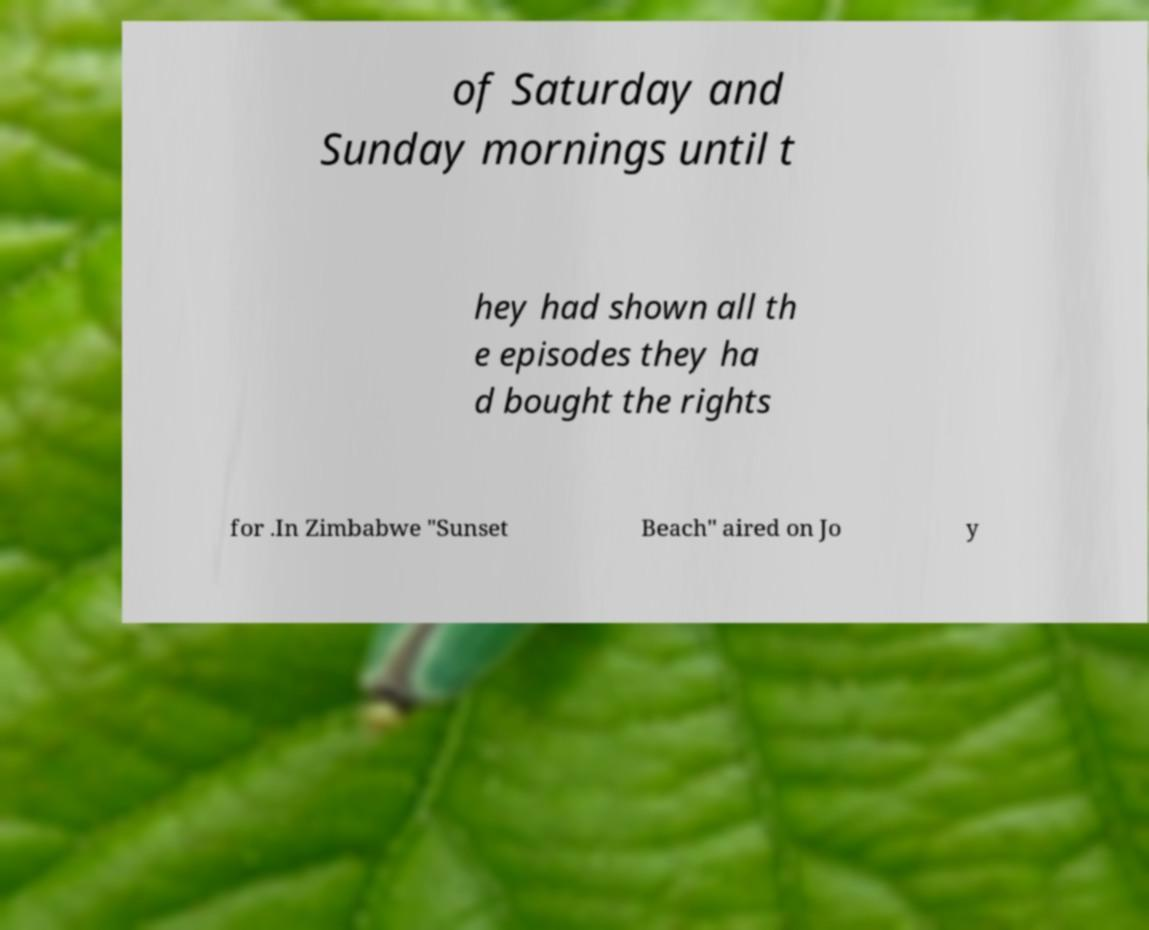Could you assist in decoding the text presented in this image and type it out clearly? of Saturday and Sunday mornings until t hey had shown all th e episodes they ha d bought the rights for .In Zimbabwe "Sunset Beach" aired on Jo y 